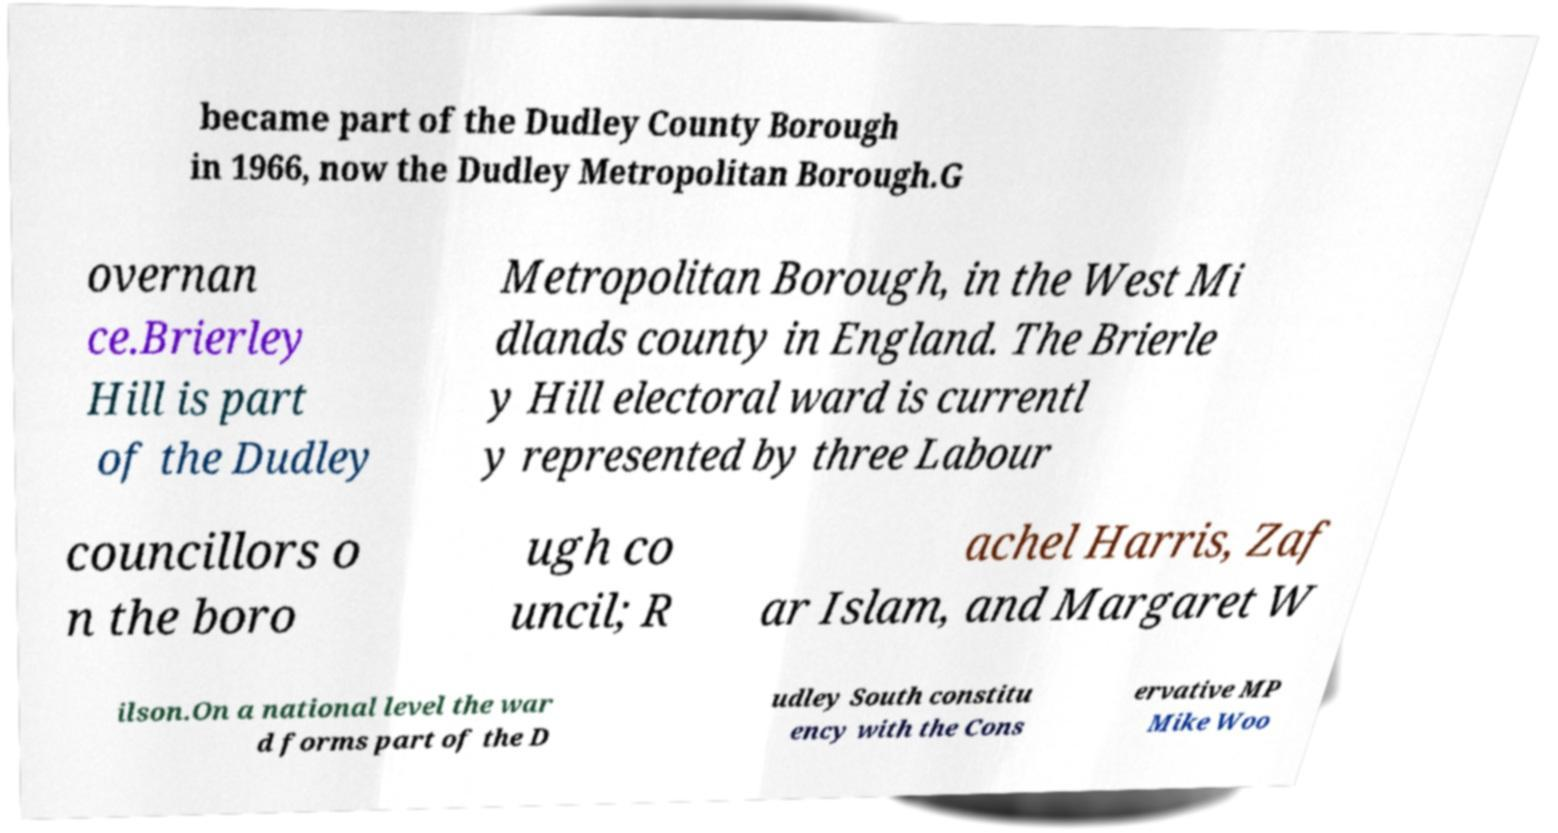For documentation purposes, I need the text within this image transcribed. Could you provide that? became part of the Dudley County Borough in 1966, now the Dudley Metropolitan Borough.G overnan ce.Brierley Hill is part of the Dudley Metropolitan Borough, in the West Mi dlands county in England. The Brierle y Hill electoral ward is currentl y represented by three Labour councillors o n the boro ugh co uncil; R achel Harris, Zaf ar Islam, and Margaret W ilson.On a national level the war d forms part of the D udley South constitu ency with the Cons ervative MP Mike Woo 